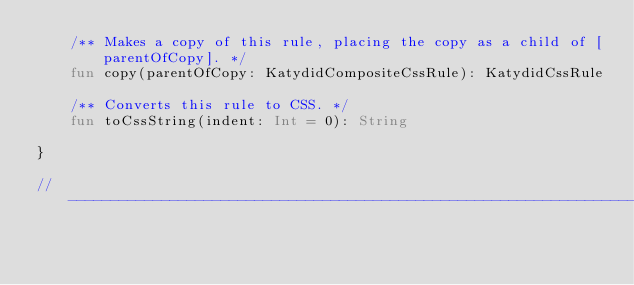Convert code to text. <code><loc_0><loc_0><loc_500><loc_500><_Kotlin_>    /** Makes a copy of this rule, placing the copy as a child of [parentOfCopy]. */
    fun copy(parentOfCopy: KatydidCompositeCssRule): KatydidCssRule

    /** Converts this rule to CSS. */
    fun toCssString(indent: Int = 0): String

}

//---------------------------------------------------------------------------------------------------------------------

</code> 